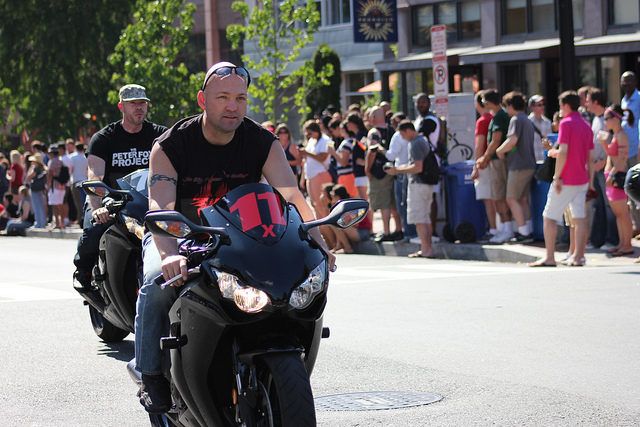Extract all visible text content from this image. 11 X PETER PROJEC FO 